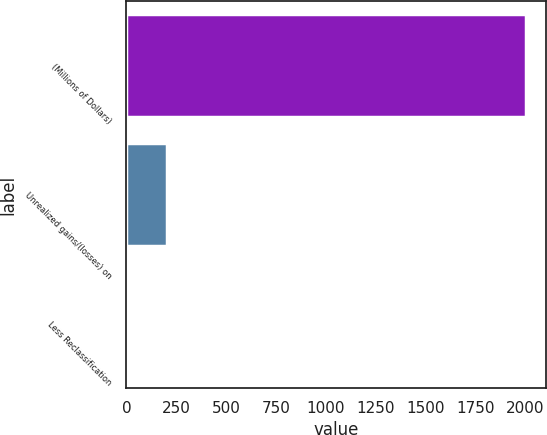Convert chart. <chart><loc_0><loc_0><loc_500><loc_500><bar_chart><fcel>(Millions of Dollars)<fcel>Unrealized gains/(losses) on<fcel>Less Reclassification<nl><fcel>2003<fcel>201.2<fcel>1<nl></chart> 